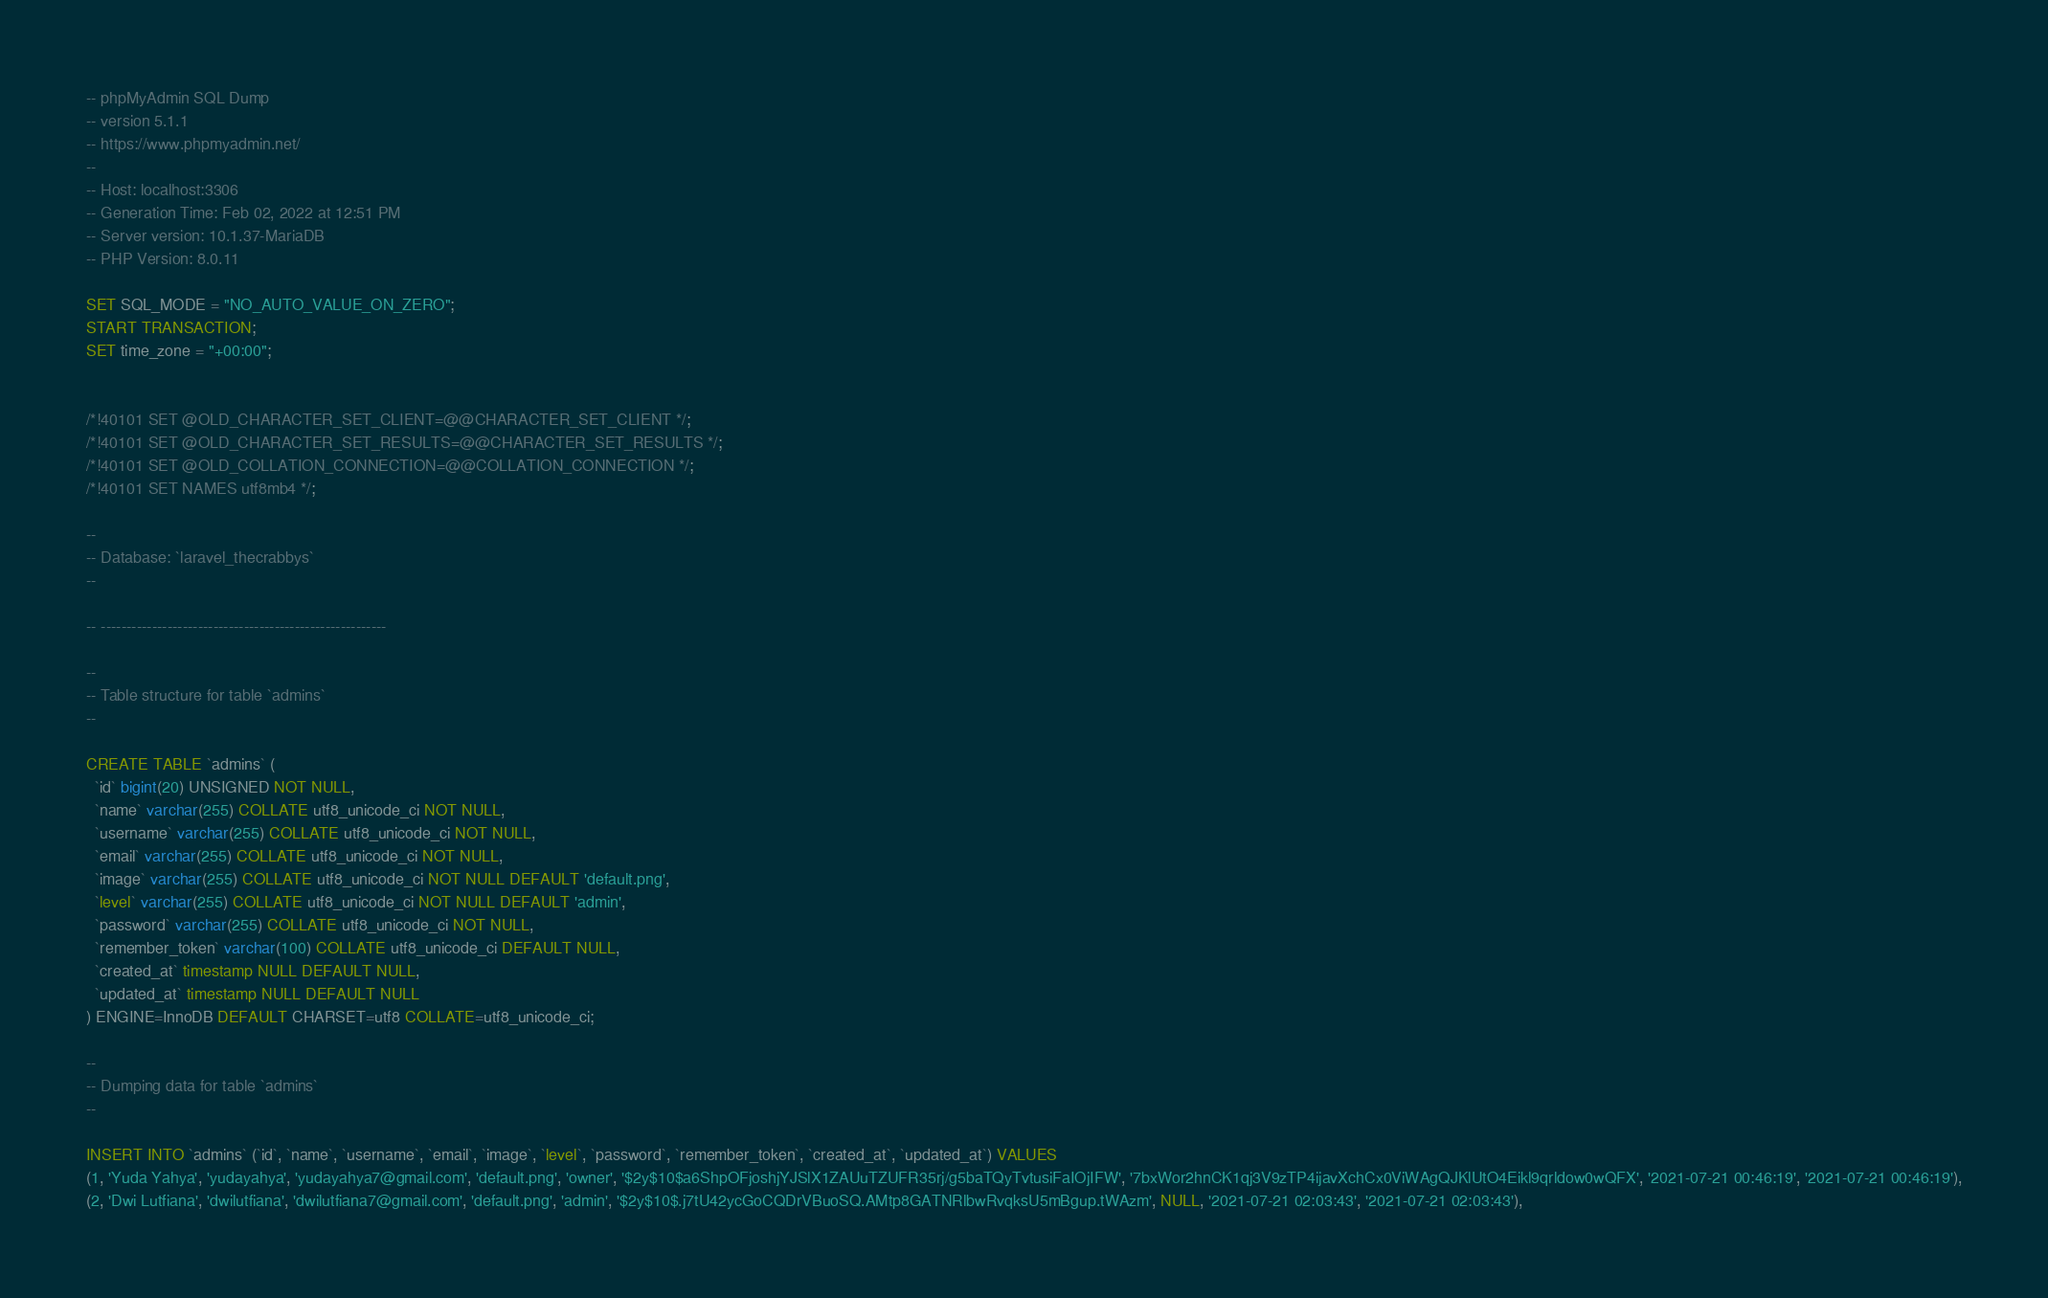<code> <loc_0><loc_0><loc_500><loc_500><_SQL_>-- phpMyAdmin SQL Dump
-- version 5.1.1
-- https://www.phpmyadmin.net/
--
-- Host: localhost:3306
-- Generation Time: Feb 02, 2022 at 12:51 PM
-- Server version: 10.1.37-MariaDB
-- PHP Version: 8.0.11

SET SQL_MODE = "NO_AUTO_VALUE_ON_ZERO";
START TRANSACTION;
SET time_zone = "+00:00";


/*!40101 SET @OLD_CHARACTER_SET_CLIENT=@@CHARACTER_SET_CLIENT */;
/*!40101 SET @OLD_CHARACTER_SET_RESULTS=@@CHARACTER_SET_RESULTS */;
/*!40101 SET @OLD_COLLATION_CONNECTION=@@COLLATION_CONNECTION */;
/*!40101 SET NAMES utf8mb4 */;

--
-- Database: `laravel_thecrabbys`
--

-- --------------------------------------------------------

--
-- Table structure for table `admins`
--

CREATE TABLE `admins` (
  `id` bigint(20) UNSIGNED NOT NULL,
  `name` varchar(255) COLLATE utf8_unicode_ci NOT NULL,
  `username` varchar(255) COLLATE utf8_unicode_ci NOT NULL,
  `email` varchar(255) COLLATE utf8_unicode_ci NOT NULL,
  `image` varchar(255) COLLATE utf8_unicode_ci NOT NULL DEFAULT 'default.png',
  `level` varchar(255) COLLATE utf8_unicode_ci NOT NULL DEFAULT 'admin',
  `password` varchar(255) COLLATE utf8_unicode_ci NOT NULL,
  `remember_token` varchar(100) COLLATE utf8_unicode_ci DEFAULT NULL,
  `created_at` timestamp NULL DEFAULT NULL,
  `updated_at` timestamp NULL DEFAULT NULL
) ENGINE=InnoDB DEFAULT CHARSET=utf8 COLLATE=utf8_unicode_ci;

--
-- Dumping data for table `admins`
--

INSERT INTO `admins` (`id`, `name`, `username`, `email`, `image`, `level`, `password`, `remember_token`, `created_at`, `updated_at`) VALUES
(1, 'Yuda Yahya', 'yudayahya', 'yudayahya7@gmail.com', 'default.png', 'owner', '$2y$10$a6ShpOFjoshjYJSlX1ZAUuTZUFR35rj/g5baTQyTvtusiFaIOjIFW', '7bxWor2hnCK1qj3V9zTP4ijavXchCx0ViWAgQJKlUtO4Eikl9qrldow0wQFX', '2021-07-21 00:46:19', '2021-07-21 00:46:19'),
(2, 'Dwi Lutfiana', 'dwilutfiana', 'dwilutfiana7@gmail.com', 'default.png', 'admin', '$2y$10$.j7tU42ycGoCQDrVBuoSQ.AMtp8GATNRlbwRvqksU5mBgup.tWAzm', NULL, '2021-07-21 02:03:43', '2021-07-21 02:03:43'),</code> 